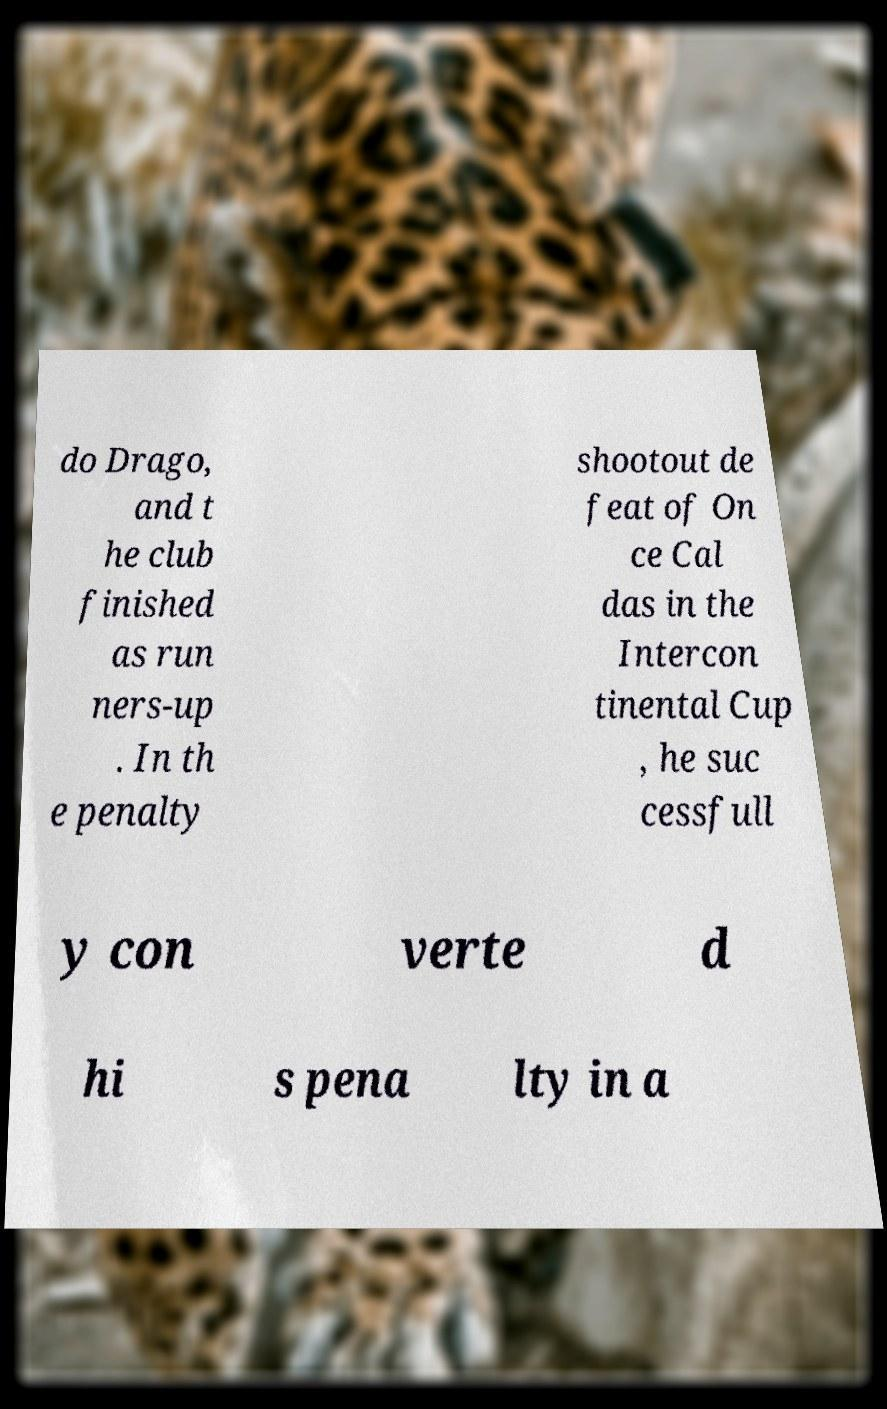Could you assist in decoding the text presented in this image and type it out clearly? do Drago, and t he club finished as run ners-up . In th e penalty shootout de feat of On ce Cal das in the Intercon tinental Cup , he suc cessfull y con verte d hi s pena lty in a 